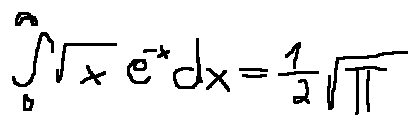<formula> <loc_0><loc_0><loc_500><loc_500>\int \lim i t s _ { 0 } ^ { \infty } \sqrt { x } e ^ { - x } d x = \frac { 1 } { 2 } \sqrt { \pi }</formula> 